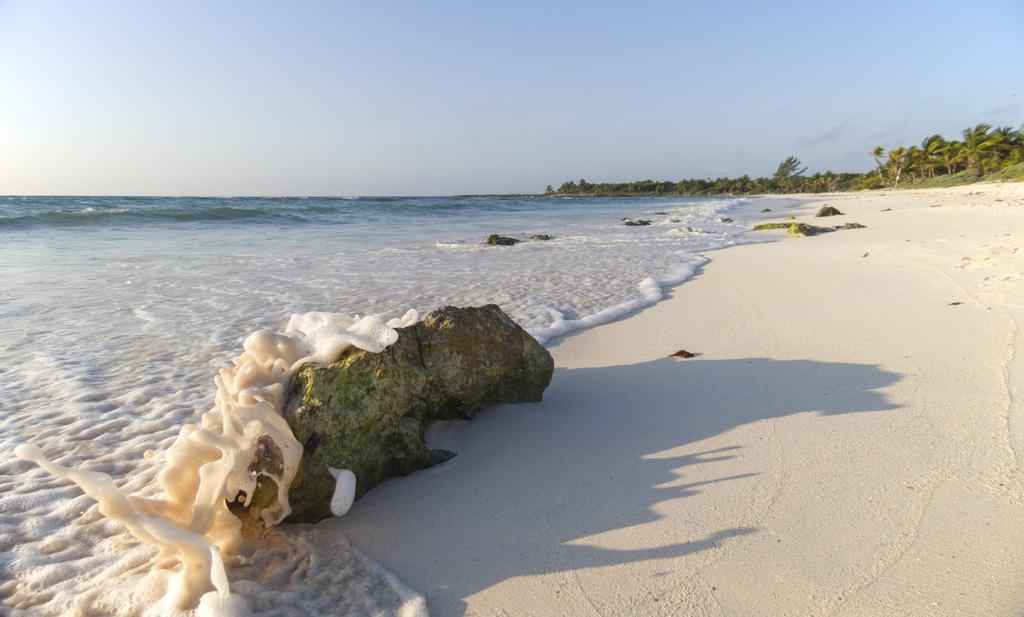In one or two sentences, can you explain what this image depicts? In this picture we can see a rock here, on the left side there is water, we can see some trees in the background, there is the sky at the top of the picture. 